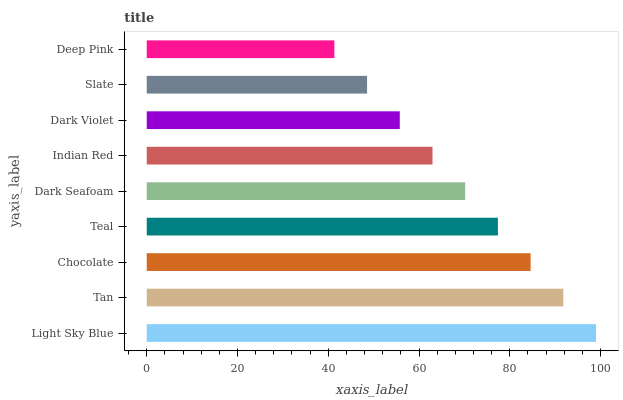Is Deep Pink the minimum?
Answer yes or no. Yes. Is Light Sky Blue the maximum?
Answer yes or no. Yes. Is Tan the minimum?
Answer yes or no. No. Is Tan the maximum?
Answer yes or no. No. Is Light Sky Blue greater than Tan?
Answer yes or no. Yes. Is Tan less than Light Sky Blue?
Answer yes or no. Yes. Is Tan greater than Light Sky Blue?
Answer yes or no. No. Is Light Sky Blue less than Tan?
Answer yes or no. No. Is Dark Seafoam the high median?
Answer yes or no. Yes. Is Dark Seafoam the low median?
Answer yes or no. Yes. Is Dark Violet the high median?
Answer yes or no. No. Is Dark Violet the low median?
Answer yes or no. No. 